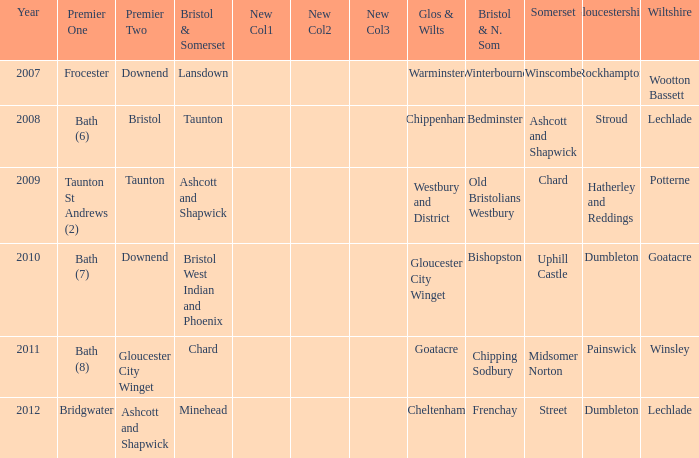What is the glos & wilts where the bristol & somerset is lansdown? Warminster. 